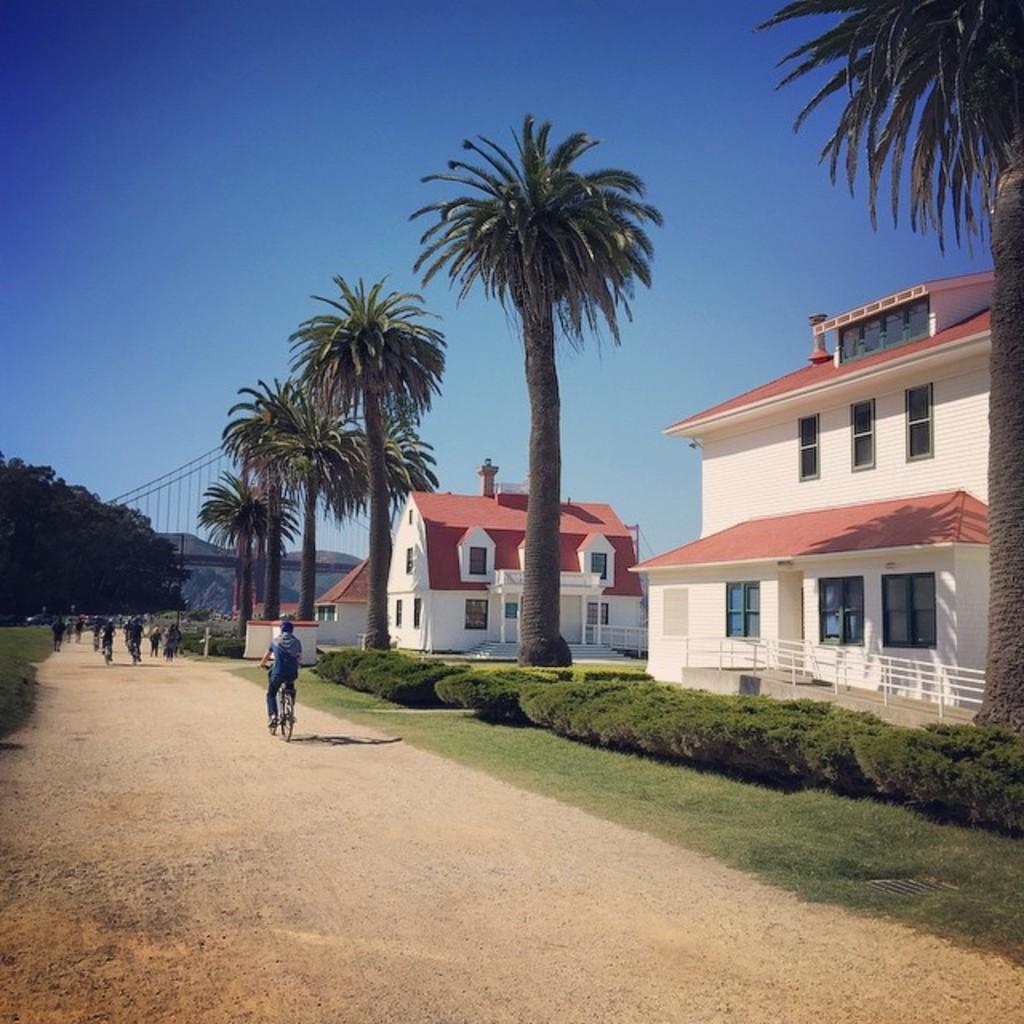Can you describe this image briefly? In this image there is a road on which there are people cycling. On the right side there are two houses with the windows. Beside the road there is a garden which has plants in it. On the left side there is a tree in the background. In front of the houses there are tall trees. 